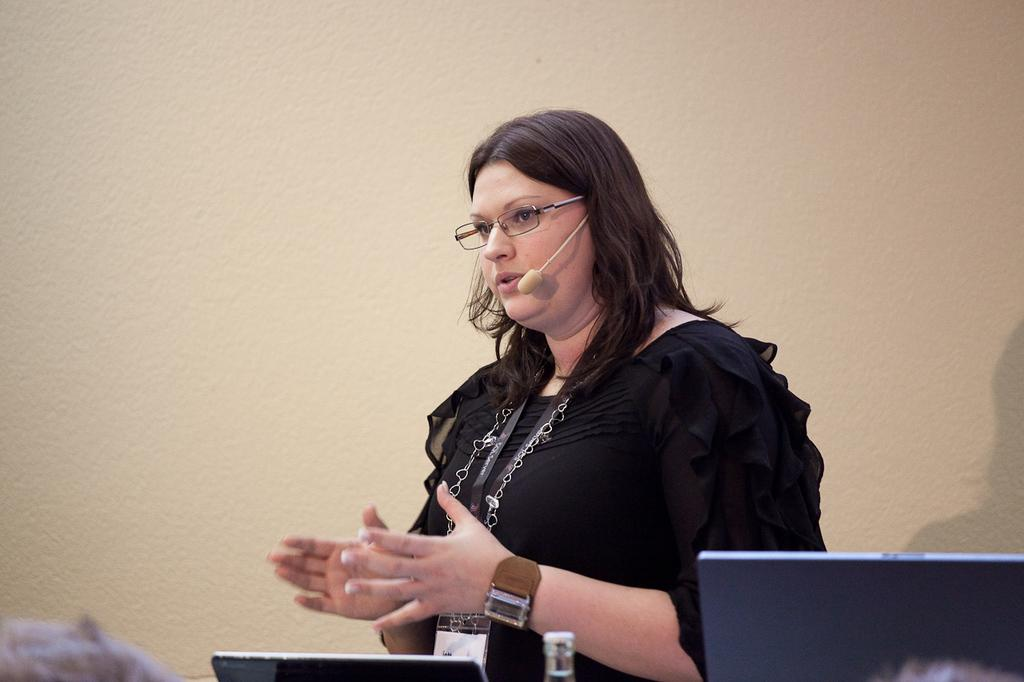Who is present in the image? There is a woman in the image. What is the woman wearing? The woman is wearing glasses (specs). What electronic devices can be seen in the image? There are laptops in the image. What is the background of the image? There is a wall in the image. What type of drain is visible in the image? There is no drain present in the image. What kind of bomb is the woman holding in the image? There is no bomb present in the image; the woman is simply wearing glasses and there are laptops and a wall visible. 